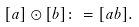<formula> <loc_0><loc_0><loc_500><loc_500>[ a ] \odot [ b ] \colon = [ a b ] .</formula> 